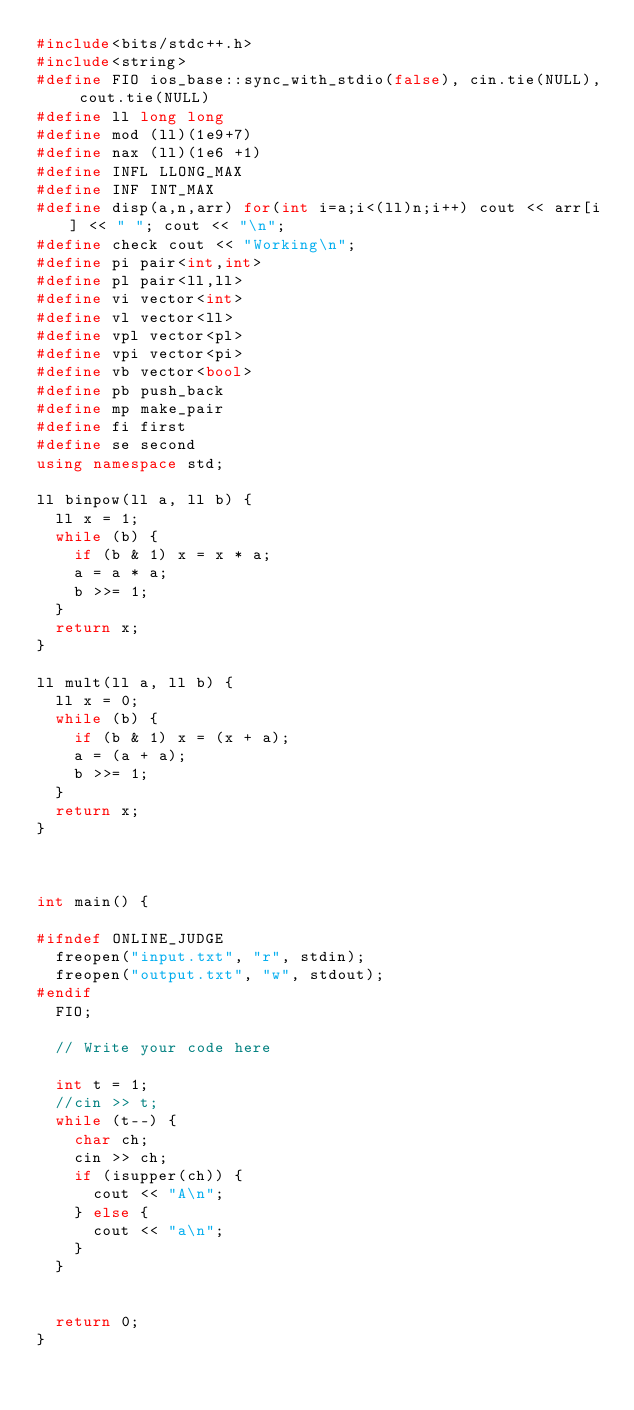<code> <loc_0><loc_0><loc_500><loc_500><_C++_>#include<bits/stdc++.h>
#include<string>
#define FIO ios_base::sync_with_stdio(false), cin.tie(NULL), cout.tie(NULL)
#define ll long long
#define mod (ll)(1e9+7)
#define nax (ll)(1e6 +1)
#define INFL LLONG_MAX
#define INF INT_MAX
#define disp(a,n,arr) for(int i=a;i<(ll)n;i++) cout << arr[i] << " "; cout << "\n";
#define check cout << "Working\n";
#define pi pair<int,int>
#define pl pair<ll,ll>
#define vi vector<int>
#define vl vector<ll>
#define vpl vector<pl>
#define vpi vector<pi>
#define vb vector<bool>
#define pb push_back
#define mp make_pair
#define fi first
#define se second
using namespace std;

ll binpow(ll a, ll b) {
	ll x = 1;
	while (b) {
		if (b & 1) x = x * a;
		a = a * a;
		b >>= 1;
	}
	return x;
}

ll mult(ll a, ll b) {
	ll x = 0;
	while (b) {
		if (b & 1) x = (x + a);
		a = (a + a);
		b >>= 1;
	}
	return x;
}



int main() {

#ifndef ONLINE_JUDGE
	freopen("input.txt", "r", stdin);
	freopen("output.txt", "w", stdout);
#endif
	FIO;

	// Write your code here

	int t = 1;
	//cin >> t;
	while (t--) {
		char ch;
		cin >> ch;
		if (isupper(ch)) {
			cout << "A\n";
		} else {
			cout << "a\n";
		}
	}


	return 0;
}</code> 